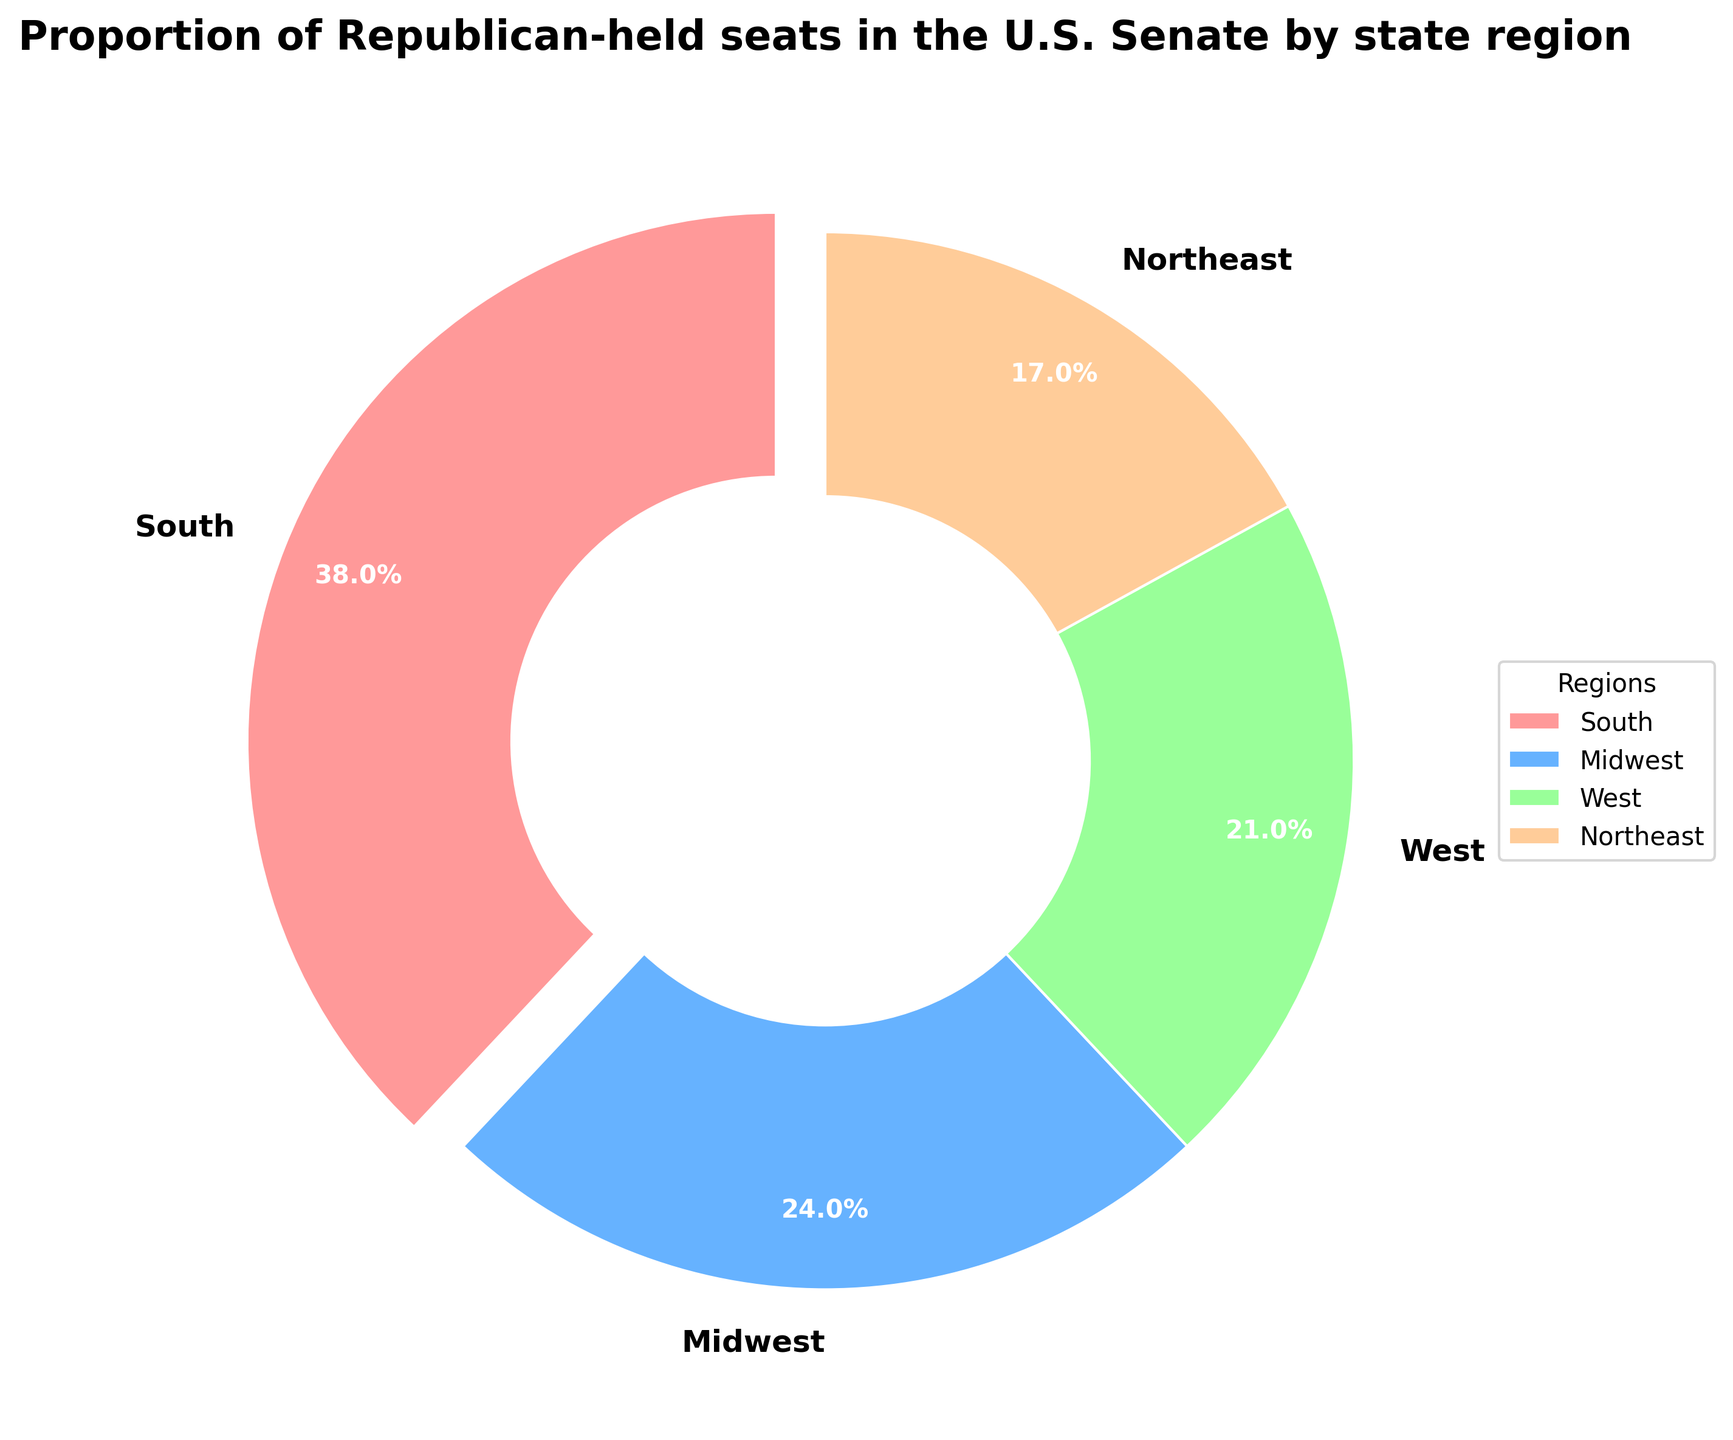What is the region with the highest proportion of Republican-held seats in the U.S. Senate? The region with the highest proportion can be identified as the one with the largest percentage label. From the pie chart, the South has the highest proportion at 38%.
Answer: South Which region has a lower proportion of Republican-held seats: Midwest or West? To determine which region has a lower proportion, compare the percentage labels for Midwest and West. Midwest has 24% and West has 21%, so West has a lower proportion.
Answer: West What is the total proportion of Republican-held seats in the Northeast and Midwest combined? To find the total proportion, add the percentages of the Northeast and Midwest. Northeast has 17% and Midwest has 24%, so 17% + 24% = 41%.
Answer: 41% By how much does the South's proportion exceed the Northeast's proportion of Republican-held seats? Subtract the Northeast percentage from the South percentage to find the difference. South has 38% and Northeast has 17%, so 38% - 17% = 21%.
Answer: 21% What is the average proportion of Republican-held seats across all regions? To compute the average, sum up all the proportions and divide by the number of regions. (38% + 24% + 21% + 17%) / 4 = 100% / 4 = 25%.
Answer: 25% Which region has the smallest proportion of Republican-held seats in the U.S. Senate? Identify the region with the smallest percentage label. The Northeast has the smallest proportion at 17%.
Answer: Northeast Which regions together make up more than half of the Republican-held seats in the U.S. Senate? Combine different regions and check their total proportion. South (38%) and Midwest (24%) together make up 62%, which is more than half.
Answer: South and Midwest What is the proportion difference between the West and Midwest regions? Subtract the West's proportion from the Midwest's proportion to find the difference. Midwest has 24% and West has 21%, so 24% - 21% = 3%.
Answer: 3% What color represents the region with the highest proportion of Republican-held seats in the pie chart? Identify the color used for the region with the highest proportion (South). The South is colored in red.
Answer: Red How many regions have more Republican-held seats than the Northeast? Count the regions with a higher percentage than the Northeast’s 17%. South (38%), Midwest (24%), and West (21%) are all higher. Thus, there are 3 regions.
Answer: 3 